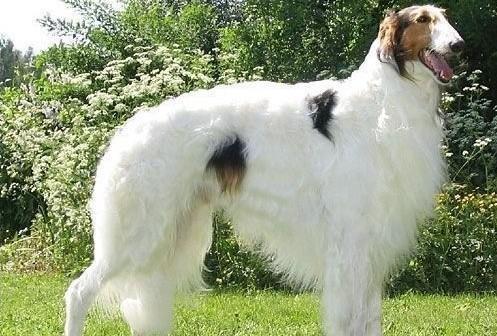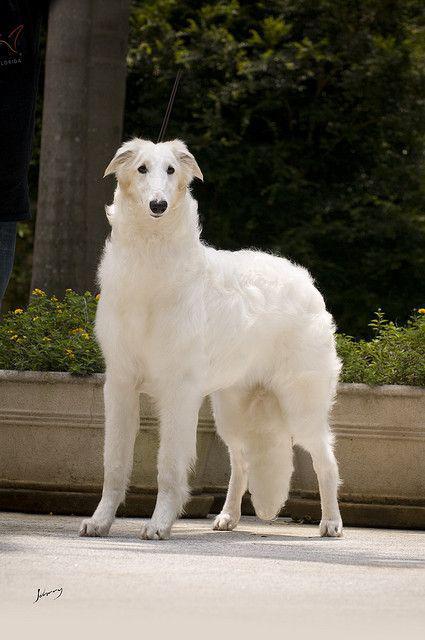The first image is the image on the left, the second image is the image on the right. Evaluate the accuracy of this statement regarding the images: "All images show hounds standing on the grass.". Is it true? Answer yes or no. No. The first image is the image on the left, the second image is the image on the right. For the images displayed, is the sentence "All of the dogs are facing the same way." factually correct? Answer yes or no. No. 